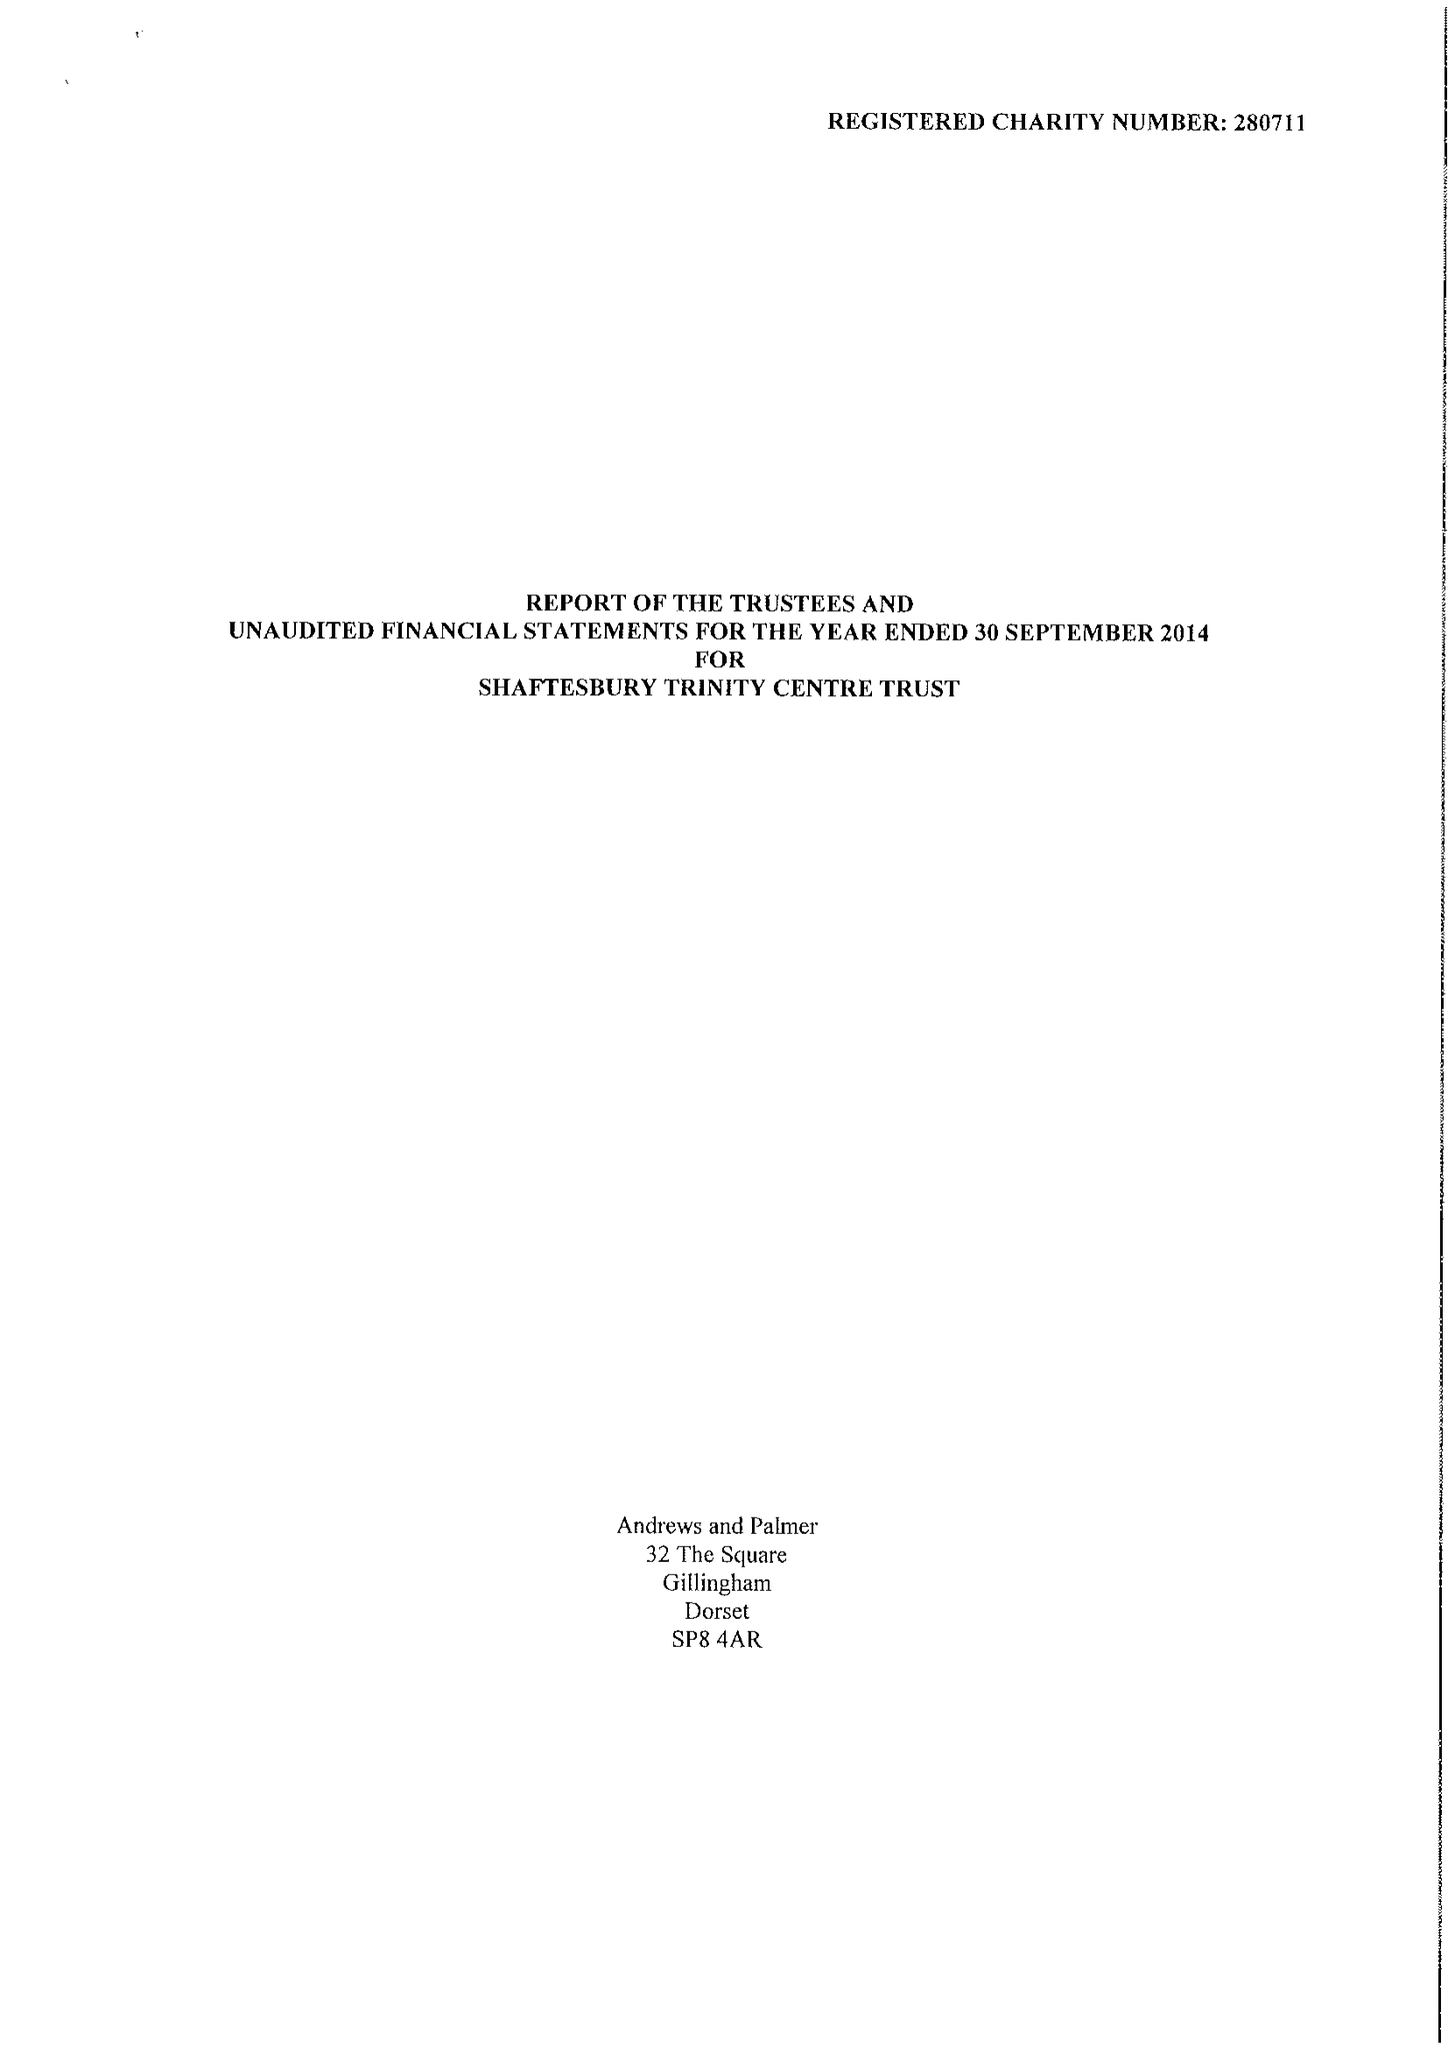What is the value for the spending_annually_in_british_pounds?
Answer the question using a single word or phrase. 24008.00 